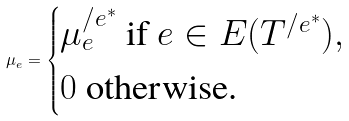<formula> <loc_0><loc_0><loc_500><loc_500>\mu _ { e } = \begin{cases} \mu ^ { / e ^ { * } } _ { e } \text { if } e \in E ( T ^ { / e ^ { * } } ) , \\ 0 \text { otherwise.} \end{cases}</formula> 